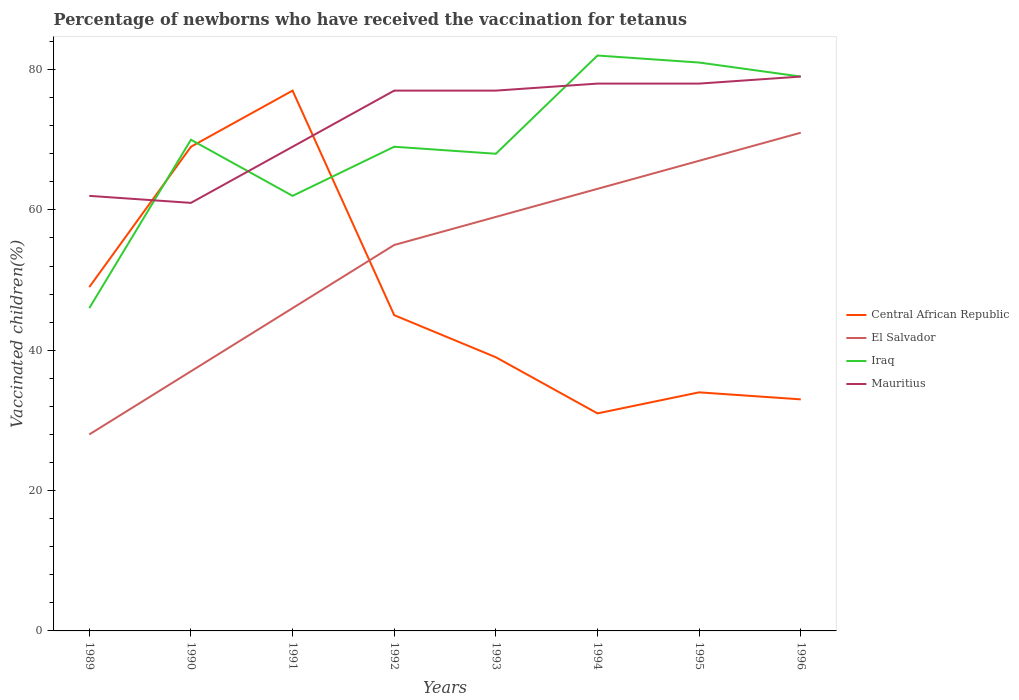How many different coloured lines are there?
Your answer should be very brief. 4. Across all years, what is the maximum percentage of vaccinated children in Central African Republic?
Provide a short and direct response. 31. What is the total percentage of vaccinated children in Central African Republic in the graph?
Provide a short and direct response. 8. What is the difference between the highest and the second highest percentage of vaccinated children in Central African Republic?
Your answer should be compact. 46. What is the difference between two consecutive major ticks on the Y-axis?
Offer a very short reply. 20. Are the values on the major ticks of Y-axis written in scientific E-notation?
Your answer should be compact. No. Does the graph contain grids?
Make the answer very short. No. Where does the legend appear in the graph?
Make the answer very short. Center right. What is the title of the graph?
Make the answer very short. Percentage of newborns who have received the vaccination for tetanus. What is the label or title of the X-axis?
Your answer should be very brief. Years. What is the label or title of the Y-axis?
Provide a short and direct response. Vaccinated children(%). What is the Vaccinated children(%) of Iraq in 1989?
Your answer should be very brief. 46. What is the Vaccinated children(%) in Mauritius in 1989?
Your answer should be very brief. 62. What is the Vaccinated children(%) of Central African Republic in 1990?
Make the answer very short. 69. What is the Vaccinated children(%) in Iraq in 1990?
Ensure brevity in your answer.  70. What is the Vaccinated children(%) in Mauritius in 1990?
Provide a short and direct response. 61. What is the Vaccinated children(%) of Central African Republic in 1991?
Keep it short and to the point. 77. What is the Vaccinated children(%) in El Salvador in 1991?
Provide a succinct answer. 46. What is the Vaccinated children(%) in El Salvador in 1992?
Ensure brevity in your answer.  55. What is the Vaccinated children(%) of Iraq in 1992?
Ensure brevity in your answer.  69. What is the Vaccinated children(%) in Mauritius in 1992?
Your answer should be compact. 77. What is the Vaccinated children(%) of Central African Republic in 1993?
Offer a terse response. 39. What is the Vaccinated children(%) in El Salvador in 1993?
Keep it short and to the point. 59. What is the Vaccinated children(%) of Central African Republic in 1994?
Provide a short and direct response. 31. What is the Vaccinated children(%) of Iraq in 1995?
Your response must be concise. 81. What is the Vaccinated children(%) in Mauritius in 1995?
Give a very brief answer. 78. What is the Vaccinated children(%) in Iraq in 1996?
Provide a short and direct response. 79. What is the Vaccinated children(%) in Mauritius in 1996?
Provide a short and direct response. 79. Across all years, what is the maximum Vaccinated children(%) in Central African Republic?
Ensure brevity in your answer.  77. Across all years, what is the maximum Vaccinated children(%) in Iraq?
Your answer should be very brief. 82. Across all years, what is the maximum Vaccinated children(%) of Mauritius?
Provide a short and direct response. 79. Across all years, what is the minimum Vaccinated children(%) in Central African Republic?
Ensure brevity in your answer.  31. Across all years, what is the minimum Vaccinated children(%) of El Salvador?
Make the answer very short. 28. What is the total Vaccinated children(%) of Central African Republic in the graph?
Your answer should be very brief. 377. What is the total Vaccinated children(%) of El Salvador in the graph?
Keep it short and to the point. 426. What is the total Vaccinated children(%) in Iraq in the graph?
Your answer should be very brief. 557. What is the total Vaccinated children(%) of Mauritius in the graph?
Provide a short and direct response. 581. What is the difference between the Vaccinated children(%) in Iraq in 1989 and that in 1990?
Ensure brevity in your answer.  -24. What is the difference between the Vaccinated children(%) in Iraq in 1989 and that in 1991?
Offer a very short reply. -16. What is the difference between the Vaccinated children(%) in El Salvador in 1989 and that in 1993?
Ensure brevity in your answer.  -31. What is the difference between the Vaccinated children(%) in Iraq in 1989 and that in 1993?
Provide a short and direct response. -22. What is the difference between the Vaccinated children(%) in El Salvador in 1989 and that in 1994?
Offer a very short reply. -35. What is the difference between the Vaccinated children(%) of Iraq in 1989 and that in 1994?
Your answer should be compact. -36. What is the difference between the Vaccinated children(%) in El Salvador in 1989 and that in 1995?
Offer a very short reply. -39. What is the difference between the Vaccinated children(%) of Iraq in 1989 and that in 1995?
Ensure brevity in your answer.  -35. What is the difference between the Vaccinated children(%) of Mauritius in 1989 and that in 1995?
Offer a terse response. -16. What is the difference between the Vaccinated children(%) of Central African Republic in 1989 and that in 1996?
Provide a succinct answer. 16. What is the difference between the Vaccinated children(%) in El Salvador in 1989 and that in 1996?
Your response must be concise. -43. What is the difference between the Vaccinated children(%) of Iraq in 1989 and that in 1996?
Offer a terse response. -33. What is the difference between the Vaccinated children(%) of Mauritius in 1989 and that in 1996?
Your answer should be very brief. -17. What is the difference between the Vaccinated children(%) in Mauritius in 1990 and that in 1991?
Ensure brevity in your answer.  -8. What is the difference between the Vaccinated children(%) of El Salvador in 1990 and that in 1992?
Provide a short and direct response. -18. What is the difference between the Vaccinated children(%) of Iraq in 1990 and that in 1992?
Your answer should be very brief. 1. What is the difference between the Vaccinated children(%) of Mauritius in 1990 and that in 1992?
Offer a terse response. -16. What is the difference between the Vaccinated children(%) of Central African Republic in 1990 and that in 1993?
Your response must be concise. 30. What is the difference between the Vaccinated children(%) of Central African Republic in 1990 and that in 1994?
Give a very brief answer. 38. What is the difference between the Vaccinated children(%) in El Salvador in 1990 and that in 1994?
Ensure brevity in your answer.  -26. What is the difference between the Vaccinated children(%) in Iraq in 1990 and that in 1994?
Ensure brevity in your answer.  -12. What is the difference between the Vaccinated children(%) of Mauritius in 1990 and that in 1994?
Your answer should be compact. -17. What is the difference between the Vaccinated children(%) of El Salvador in 1990 and that in 1995?
Ensure brevity in your answer.  -30. What is the difference between the Vaccinated children(%) in Iraq in 1990 and that in 1995?
Your answer should be compact. -11. What is the difference between the Vaccinated children(%) in El Salvador in 1990 and that in 1996?
Offer a terse response. -34. What is the difference between the Vaccinated children(%) in Mauritius in 1990 and that in 1996?
Provide a succinct answer. -18. What is the difference between the Vaccinated children(%) of El Salvador in 1991 and that in 1992?
Your answer should be very brief. -9. What is the difference between the Vaccinated children(%) in Mauritius in 1991 and that in 1992?
Ensure brevity in your answer.  -8. What is the difference between the Vaccinated children(%) of Central African Republic in 1991 and that in 1993?
Your answer should be very brief. 38. What is the difference between the Vaccinated children(%) in El Salvador in 1991 and that in 1993?
Your answer should be compact. -13. What is the difference between the Vaccinated children(%) of Iraq in 1991 and that in 1993?
Your response must be concise. -6. What is the difference between the Vaccinated children(%) of Mauritius in 1991 and that in 1993?
Offer a terse response. -8. What is the difference between the Vaccinated children(%) in El Salvador in 1991 and that in 1994?
Provide a short and direct response. -17. What is the difference between the Vaccinated children(%) in Mauritius in 1991 and that in 1994?
Your answer should be very brief. -9. What is the difference between the Vaccinated children(%) in El Salvador in 1991 and that in 1995?
Offer a very short reply. -21. What is the difference between the Vaccinated children(%) in Iraq in 1991 and that in 1995?
Ensure brevity in your answer.  -19. What is the difference between the Vaccinated children(%) in El Salvador in 1991 and that in 1996?
Your response must be concise. -25. What is the difference between the Vaccinated children(%) of Iraq in 1991 and that in 1996?
Make the answer very short. -17. What is the difference between the Vaccinated children(%) in Mauritius in 1991 and that in 1996?
Keep it short and to the point. -10. What is the difference between the Vaccinated children(%) of Central African Republic in 1992 and that in 1993?
Ensure brevity in your answer.  6. What is the difference between the Vaccinated children(%) of Mauritius in 1992 and that in 1993?
Your answer should be compact. 0. What is the difference between the Vaccinated children(%) of El Salvador in 1992 and that in 1994?
Ensure brevity in your answer.  -8. What is the difference between the Vaccinated children(%) in Iraq in 1992 and that in 1994?
Your answer should be very brief. -13. What is the difference between the Vaccinated children(%) of Central African Republic in 1992 and that in 1995?
Keep it short and to the point. 11. What is the difference between the Vaccinated children(%) in El Salvador in 1992 and that in 1995?
Your answer should be compact. -12. What is the difference between the Vaccinated children(%) in Iraq in 1992 and that in 1995?
Provide a succinct answer. -12. What is the difference between the Vaccinated children(%) of El Salvador in 1992 and that in 1996?
Make the answer very short. -16. What is the difference between the Vaccinated children(%) of Mauritius in 1993 and that in 1994?
Your response must be concise. -1. What is the difference between the Vaccinated children(%) in Central African Republic in 1993 and that in 1995?
Give a very brief answer. 5. What is the difference between the Vaccinated children(%) of Iraq in 1993 and that in 1995?
Keep it short and to the point. -13. What is the difference between the Vaccinated children(%) of Mauritius in 1993 and that in 1995?
Give a very brief answer. -1. What is the difference between the Vaccinated children(%) of Central African Republic in 1993 and that in 1996?
Provide a short and direct response. 6. What is the difference between the Vaccinated children(%) of El Salvador in 1993 and that in 1996?
Give a very brief answer. -12. What is the difference between the Vaccinated children(%) of Iraq in 1993 and that in 1996?
Provide a short and direct response. -11. What is the difference between the Vaccinated children(%) of Mauritius in 1993 and that in 1996?
Your answer should be very brief. -2. What is the difference between the Vaccinated children(%) of El Salvador in 1994 and that in 1995?
Provide a short and direct response. -4. What is the difference between the Vaccinated children(%) of Iraq in 1994 and that in 1995?
Your answer should be very brief. 1. What is the difference between the Vaccinated children(%) in Mauritius in 1994 and that in 1995?
Your response must be concise. 0. What is the difference between the Vaccinated children(%) in Central African Republic in 1994 and that in 1996?
Offer a very short reply. -2. What is the difference between the Vaccinated children(%) of El Salvador in 1994 and that in 1996?
Give a very brief answer. -8. What is the difference between the Vaccinated children(%) of Central African Republic in 1995 and that in 1996?
Ensure brevity in your answer.  1. What is the difference between the Vaccinated children(%) in El Salvador in 1995 and that in 1996?
Your answer should be very brief. -4. What is the difference between the Vaccinated children(%) of Iraq in 1995 and that in 1996?
Provide a succinct answer. 2. What is the difference between the Vaccinated children(%) in Central African Republic in 1989 and the Vaccinated children(%) in El Salvador in 1990?
Make the answer very short. 12. What is the difference between the Vaccinated children(%) in Central African Republic in 1989 and the Vaccinated children(%) in Iraq in 1990?
Keep it short and to the point. -21. What is the difference between the Vaccinated children(%) in Central African Republic in 1989 and the Vaccinated children(%) in Mauritius in 1990?
Provide a short and direct response. -12. What is the difference between the Vaccinated children(%) in El Salvador in 1989 and the Vaccinated children(%) in Iraq in 1990?
Keep it short and to the point. -42. What is the difference between the Vaccinated children(%) of El Salvador in 1989 and the Vaccinated children(%) of Mauritius in 1990?
Your answer should be compact. -33. What is the difference between the Vaccinated children(%) of Central African Republic in 1989 and the Vaccinated children(%) of Mauritius in 1991?
Your answer should be very brief. -20. What is the difference between the Vaccinated children(%) of El Salvador in 1989 and the Vaccinated children(%) of Iraq in 1991?
Offer a terse response. -34. What is the difference between the Vaccinated children(%) of El Salvador in 1989 and the Vaccinated children(%) of Mauritius in 1991?
Give a very brief answer. -41. What is the difference between the Vaccinated children(%) of Central African Republic in 1989 and the Vaccinated children(%) of Iraq in 1992?
Offer a terse response. -20. What is the difference between the Vaccinated children(%) in El Salvador in 1989 and the Vaccinated children(%) in Iraq in 1992?
Offer a terse response. -41. What is the difference between the Vaccinated children(%) in El Salvador in 1989 and the Vaccinated children(%) in Mauritius in 1992?
Provide a short and direct response. -49. What is the difference between the Vaccinated children(%) in Iraq in 1989 and the Vaccinated children(%) in Mauritius in 1992?
Offer a very short reply. -31. What is the difference between the Vaccinated children(%) of Central African Republic in 1989 and the Vaccinated children(%) of El Salvador in 1993?
Provide a short and direct response. -10. What is the difference between the Vaccinated children(%) in Central African Republic in 1989 and the Vaccinated children(%) in Mauritius in 1993?
Your answer should be very brief. -28. What is the difference between the Vaccinated children(%) in El Salvador in 1989 and the Vaccinated children(%) in Iraq in 1993?
Your answer should be very brief. -40. What is the difference between the Vaccinated children(%) in El Salvador in 1989 and the Vaccinated children(%) in Mauritius in 1993?
Your answer should be compact. -49. What is the difference between the Vaccinated children(%) in Iraq in 1989 and the Vaccinated children(%) in Mauritius in 1993?
Give a very brief answer. -31. What is the difference between the Vaccinated children(%) of Central African Republic in 1989 and the Vaccinated children(%) of Iraq in 1994?
Ensure brevity in your answer.  -33. What is the difference between the Vaccinated children(%) of Central African Republic in 1989 and the Vaccinated children(%) of Mauritius in 1994?
Make the answer very short. -29. What is the difference between the Vaccinated children(%) of El Salvador in 1989 and the Vaccinated children(%) of Iraq in 1994?
Give a very brief answer. -54. What is the difference between the Vaccinated children(%) in El Salvador in 1989 and the Vaccinated children(%) in Mauritius in 1994?
Your answer should be compact. -50. What is the difference between the Vaccinated children(%) of Iraq in 1989 and the Vaccinated children(%) of Mauritius in 1994?
Provide a succinct answer. -32. What is the difference between the Vaccinated children(%) in Central African Republic in 1989 and the Vaccinated children(%) in El Salvador in 1995?
Your answer should be compact. -18. What is the difference between the Vaccinated children(%) in Central African Republic in 1989 and the Vaccinated children(%) in Iraq in 1995?
Ensure brevity in your answer.  -32. What is the difference between the Vaccinated children(%) in El Salvador in 1989 and the Vaccinated children(%) in Iraq in 1995?
Give a very brief answer. -53. What is the difference between the Vaccinated children(%) in El Salvador in 1989 and the Vaccinated children(%) in Mauritius in 1995?
Your answer should be compact. -50. What is the difference between the Vaccinated children(%) of Iraq in 1989 and the Vaccinated children(%) of Mauritius in 1995?
Provide a short and direct response. -32. What is the difference between the Vaccinated children(%) in El Salvador in 1989 and the Vaccinated children(%) in Iraq in 1996?
Offer a terse response. -51. What is the difference between the Vaccinated children(%) in El Salvador in 1989 and the Vaccinated children(%) in Mauritius in 1996?
Your answer should be compact. -51. What is the difference between the Vaccinated children(%) in Iraq in 1989 and the Vaccinated children(%) in Mauritius in 1996?
Offer a very short reply. -33. What is the difference between the Vaccinated children(%) of Central African Republic in 1990 and the Vaccinated children(%) of Iraq in 1991?
Give a very brief answer. 7. What is the difference between the Vaccinated children(%) in El Salvador in 1990 and the Vaccinated children(%) in Mauritius in 1991?
Make the answer very short. -32. What is the difference between the Vaccinated children(%) in Iraq in 1990 and the Vaccinated children(%) in Mauritius in 1991?
Provide a short and direct response. 1. What is the difference between the Vaccinated children(%) of Central African Republic in 1990 and the Vaccinated children(%) of Iraq in 1992?
Your response must be concise. 0. What is the difference between the Vaccinated children(%) in El Salvador in 1990 and the Vaccinated children(%) in Iraq in 1992?
Give a very brief answer. -32. What is the difference between the Vaccinated children(%) of El Salvador in 1990 and the Vaccinated children(%) of Mauritius in 1992?
Provide a short and direct response. -40. What is the difference between the Vaccinated children(%) in Central African Republic in 1990 and the Vaccinated children(%) in Mauritius in 1993?
Provide a short and direct response. -8. What is the difference between the Vaccinated children(%) in El Salvador in 1990 and the Vaccinated children(%) in Iraq in 1993?
Your response must be concise. -31. What is the difference between the Vaccinated children(%) in El Salvador in 1990 and the Vaccinated children(%) in Mauritius in 1993?
Offer a terse response. -40. What is the difference between the Vaccinated children(%) of Central African Republic in 1990 and the Vaccinated children(%) of Iraq in 1994?
Keep it short and to the point. -13. What is the difference between the Vaccinated children(%) in Central African Republic in 1990 and the Vaccinated children(%) in Mauritius in 1994?
Ensure brevity in your answer.  -9. What is the difference between the Vaccinated children(%) in El Salvador in 1990 and the Vaccinated children(%) in Iraq in 1994?
Your answer should be compact. -45. What is the difference between the Vaccinated children(%) of El Salvador in 1990 and the Vaccinated children(%) of Mauritius in 1994?
Offer a very short reply. -41. What is the difference between the Vaccinated children(%) in Iraq in 1990 and the Vaccinated children(%) in Mauritius in 1994?
Make the answer very short. -8. What is the difference between the Vaccinated children(%) of Central African Republic in 1990 and the Vaccinated children(%) of El Salvador in 1995?
Ensure brevity in your answer.  2. What is the difference between the Vaccinated children(%) in El Salvador in 1990 and the Vaccinated children(%) in Iraq in 1995?
Offer a very short reply. -44. What is the difference between the Vaccinated children(%) in El Salvador in 1990 and the Vaccinated children(%) in Mauritius in 1995?
Your response must be concise. -41. What is the difference between the Vaccinated children(%) of Central African Republic in 1990 and the Vaccinated children(%) of Iraq in 1996?
Provide a succinct answer. -10. What is the difference between the Vaccinated children(%) in Central African Republic in 1990 and the Vaccinated children(%) in Mauritius in 1996?
Your answer should be very brief. -10. What is the difference between the Vaccinated children(%) of El Salvador in 1990 and the Vaccinated children(%) of Iraq in 1996?
Give a very brief answer. -42. What is the difference between the Vaccinated children(%) of El Salvador in 1990 and the Vaccinated children(%) of Mauritius in 1996?
Make the answer very short. -42. What is the difference between the Vaccinated children(%) of Iraq in 1990 and the Vaccinated children(%) of Mauritius in 1996?
Make the answer very short. -9. What is the difference between the Vaccinated children(%) of Central African Republic in 1991 and the Vaccinated children(%) of El Salvador in 1992?
Give a very brief answer. 22. What is the difference between the Vaccinated children(%) in Central African Republic in 1991 and the Vaccinated children(%) in Iraq in 1992?
Offer a terse response. 8. What is the difference between the Vaccinated children(%) of El Salvador in 1991 and the Vaccinated children(%) of Mauritius in 1992?
Offer a very short reply. -31. What is the difference between the Vaccinated children(%) in El Salvador in 1991 and the Vaccinated children(%) in Iraq in 1993?
Your answer should be very brief. -22. What is the difference between the Vaccinated children(%) in El Salvador in 1991 and the Vaccinated children(%) in Mauritius in 1993?
Ensure brevity in your answer.  -31. What is the difference between the Vaccinated children(%) of Central African Republic in 1991 and the Vaccinated children(%) of El Salvador in 1994?
Give a very brief answer. 14. What is the difference between the Vaccinated children(%) of Central African Republic in 1991 and the Vaccinated children(%) of Iraq in 1994?
Offer a terse response. -5. What is the difference between the Vaccinated children(%) in El Salvador in 1991 and the Vaccinated children(%) in Iraq in 1994?
Your answer should be very brief. -36. What is the difference between the Vaccinated children(%) in El Salvador in 1991 and the Vaccinated children(%) in Mauritius in 1994?
Provide a short and direct response. -32. What is the difference between the Vaccinated children(%) in Iraq in 1991 and the Vaccinated children(%) in Mauritius in 1994?
Ensure brevity in your answer.  -16. What is the difference between the Vaccinated children(%) in Central African Republic in 1991 and the Vaccinated children(%) in El Salvador in 1995?
Give a very brief answer. 10. What is the difference between the Vaccinated children(%) in Central African Republic in 1991 and the Vaccinated children(%) in Mauritius in 1995?
Your response must be concise. -1. What is the difference between the Vaccinated children(%) in El Salvador in 1991 and the Vaccinated children(%) in Iraq in 1995?
Offer a terse response. -35. What is the difference between the Vaccinated children(%) of El Salvador in 1991 and the Vaccinated children(%) of Mauritius in 1995?
Your response must be concise. -32. What is the difference between the Vaccinated children(%) in Iraq in 1991 and the Vaccinated children(%) in Mauritius in 1995?
Your answer should be compact. -16. What is the difference between the Vaccinated children(%) in Central African Republic in 1991 and the Vaccinated children(%) in Mauritius in 1996?
Offer a very short reply. -2. What is the difference between the Vaccinated children(%) in El Salvador in 1991 and the Vaccinated children(%) in Iraq in 1996?
Provide a short and direct response. -33. What is the difference between the Vaccinated children(%) of El Salvador in 1991 and the Vaccinated children(%) of Mauritius in 1996?
Provide a short and direct response. -33. What is the difference between the Vaccinated children(%) in Central African Republic in 1992 and the Vaccinated children(%) in El Salvador in 1993?
Ensure brevity in your answer.  -14. What is the difference between the Vaccinated children(%) of Central African Republic in 1992 and the Vaccinated children(%) of Mauritius in 1993?
Offer a terse response. -32. What is the difference between the Vaccinated children(%) of El Salvador in 1992 and the Vaccinated children(%) of Iraq in 1993?
Provide a succinct answer. -13. What is the difference between the Vaccinated children(%) in El Salvador in 1992 and the Vaccinated children(%) in Mauritius in 1993?
Provide a succinct answer. -22. What is the difference between the Vaccinated children(%) of Central African Republic in 1992 and the Vaccinated children(%) of El Salvador in 1994?
Offer a very short reply. -18. What is the difference between the Vaccinated children(%) in Central African Republic in 1992 and the Vaccinated children(%) in Iraq in 1994?
Provide a short and direct response. -37. What is the difference between the Vaccinated children(%) in Central African Republic in 1992 and the Vaccinated children(%) in Mauritius in 1994?
Provide a succinct answer. -33. What is the difference between the Vaccinated children(%) of El Salvador in 1992 and the Vaccinated children(%) of Mauritius in 1994?
Keep it short and to the point. -23. What is the difference between the Vaccinated children(%) of Central African Republic in 1992 and the Vaccinated children(%) of El Salvador in 1995?
Give a very brief answer. -22. What is the difference between the Vaccinated children(%) in Central African Republic in 1992 and the Vaccinated children(%) in Iraq in 1995?
Keep it short and to the point. -36. What is the difference between the Vaccinated children(%) in Central African Republic in 1992 and the Vaccinated children(%) in Mauritius in 1995?
Offer a very short reply. -33. What is the difference between the Vaccinated children(%) in El Salvador in 1992 and the Vaccinated children(%) in Mauritius in 1995?
Offer a terse response. -23. What is the difference between the Vaccinated children(%) in Iraq in 1992 and the Vaccinated children(%) in Mauritius in 1995?
Offer a terse response. -9. What is the difference between the Vaccinated children(%) in Central African Republic in 1992 and the Vaccinated children(%) in El Salvador in 1996?
Make the answer very short. -26. What is the difference between the Vaccinated children(%) in Central African Republic in 1992 and the Vaccinated children(%) in Iraq in 1996?
Ensure brevity in your answer.  -34. What is the difference between the Vaccinated children(%) of Central African Republic in 1992 and the Vaccinated children(%) of Mauritius in 1996?
Make the answer very short. -34. What is the difference between the Vaccinated children(%) of El Salvador in 1992 and the Vaccinated children(%) of Iraq in 1996?
Ensure brevity in your answer.  -24. What is the difference between the Vaccinated children(%) of Central African Republic in 1993 and the Vaccinated children(%) of Iraq in 1994?
Give a very brief answer. -43. What is the difference between the Vaccinated children(%) of Central African Republic in 1993 and the Vaccinated children(%) of Mauritius in 1994?
Ensure brevity in your answer.  -39. What is the difference between the Vaccinated children(%) in El Salvador in 1993 and the Vaccinated children(%) in Iraq in 1994?
Keep it short and to the point. -23. What is the difference between the Vaccinated children(%) in El Salvador in 1993 and the Vaccinated children(%) in Mauritius in 1994?
Your answer should be compact. -19. What is the difference between the Vaccinated children(%) of Central African Republic in 1993 and the Vaccinated children(%) of Iraq in 1995?
Provide a succinct answer. -42. What is the difference between the Vaccinated children(%) in Central African Republic in 1993 and the Vaccinated children(%) in Mauritius in 1995?
Provide a succinct answer. -39. What is the difference between the Vaccinated children(%) of El Salvador in 1993 and the Vaccinated children(%) of Iraq in 1995?
Your response must be concise. -22. What is the difference between the Vaccinated children(%) in El Salvador in 1993 and the Vaccinated children(%) in Mauritius in 1995?
Your answer should be very brief. -19. What is the difference between the Vaccinated children(%) in Central African Republic in 1993 and the Vaccinated children(%) in El Salvador in 1996?
Provide a succinct answer. -32. What is the difference between the Vaccinated children(%) of Central African Republic in 1993 and the Vaccinated children(%) of Mauritius in 1996?
Provide a succinct answer. -40. What is the difference between the Vaccinated children(%) of El Salvador in 1993 and the Vaccinated children(%) of Iraq in 1996?
Provide a succinct answer. -20. What is the difference between the Vaccinated children(%) in El Salvador in 1993 and the Vaccinated children(%) in Mauritius in 1996?
Your response must be concise. -20. What is the difference between the Vaccinated children(%) of Iraq in 1993 and the Vaccinated children(%) of Mauritius in 1996?
Make the answer very short. -11. What is the difference between the Vaccinated children(%) in Central African Republic in 1994 and the Vaccinated children(%) in El Salvador in 1995?
Your answer should be very brief. -36. What is the difference between the Vaccinated children(%) in Central African Republic in 1994 and the Vaccinated children(%) in Iraq in 1995?
Offer a very short reply. -50. What is the difference between the Vaccinated children(%) in Central African Republic in 1994 and the Vaccinated children(%) in Mauritius in 1995?
Provide a succinct answer. -47. What is the difference between the Vaccinated children(%) of Central African Republic in 1994 and the Vaccinated children(%) of Iraq in 1996?
Provide a short and direct response. -48. What is the difference between the Vaccinated children(%) in Central African Republic in 1994 and the Vaccinated children(%) in Mauritius in 1996?
Offer a terse response. -48. What is the difference between the Vaccinated children(%) in El Salvador in 1994 and the Vaccinated children(%) in Iraq in 1996?
Give a very brief answer. -16. What is the difference between the Vaccinated children(%) in El Salvador in 1994 and the Vaccinated children(%) in Mauritius in 1996?
Give a very brief answer. -16. What is the difference between the Vaccinated children(%) in Central African Republic in 1995 and the Vaccinated children(%) in El Salvador in 1996?
Offer a terse response. -37. What is the difference between the Vaccinated children(%) in Central African Republic in 1995 and the Vaccinated children(%) in Iraq in 1996?
Keep it short and to the point. -45. What is the difference between the Vaccinated children(%) in Central African Republic in 1995 and the Vaccinated children(%) in Mauritius in 1996?
Provide a short and direct response. -45. What is the difference between the Vaccinated children(%) in El Salvador in 1995 and the Vaccinated children(%) in Iraq in 1996?
Your answer should be compact. -12. What is the difference between the Vaccinated children(%) of El Salvador in 1995 and the Vaccinated children(%) of Mauritius in 1996?
Your answer should be compact. -12. What is the average Vaccinated children(%) in Central African Republic per year?
Offer a very short reply. 47.12. What is the average Vaccinated children(%) in El Salvador per year?
Your answer should be very brief. 53.25. What is the average Vaccinated children(%) of Iraq per year?
Give a very brief answer. 69.62. What is the average Vaccinated children(%) in Mauritius per year?
Your response must be concise. 72.62. In the year 1989, what is the difference between the Vaccinated children(%) of Central African Republic and Vaccinated children(%) of Mauritius?
Your response must be concise. -13. In the year 1989, what is the difference between the Vaccinated children(%) in El Salvador and Vaccinated children(%) in Iraq?
Your answer should be very brief. -18. In the year 1989, what is the difference between the Vaccinated children(%) in El Salvador and Vaccinated children(%) in Mauritius?
Provide a short and direct response. -34. In the year 1989, what is the difference between the Vaccinated children(%) of Iraq and Vaccinated children(%) of Mauritius?
Ensure brevity in your answer.  -16. In the year 1990, what is the difference between the Vaccinated children(%) of Central African Republic and Vaccinated children(%) of El Salvador?
Make the answer very short. 32. In the year 1990, what is the difference between the Vaccinated children(%) in El Salvador and Vaccinated children(%) in Iraq?
Provide a succinct answer. -33. In the year 1990, what is the difference between the Vaccinated children(%) in El Salvador and Vaccinated children(%) in Mauritius?
Offer a very short reply. -24. In the year 1991, what is the difference between the Vaccinated children(%) of Central African Republic and Vaccinated children(%) of Iraq?
Provide a succinct answer. 15. In the year 1991, what is the difference between the Vaccinated children(%) in El Salvador and Vaccinated children(%) in Iraq?
Provide a short and direct response. -16. In the year 1992, what is the difference between the Vaccinated children(%) of Central African Republic and Vaccinated children(%) of Mauritius?
Provide a short and direct response. -32. In the year 1992, what is the difference between the Vaccinated children(%) of El Salvador and Vaccinated children(%) of Mauritius?
Ensure brevity in your answer.  -22. In the year 1992, what is the difference between the Vaccinated children(%) in Iraq and Vaccinated children(%) in Mauritius?
Make the answer very short. -8. In the year 1993, what is the difference between the Vaccinated children(%) of Central African Republic and Vaccinated children(%) of Mauritius?
Your response must be concise. -38. In the year 1993, what is the difference between the Vaccinated children(%) in El Salvador and Vaccinated children(%) in Iraq?
Give a very brief answer. -9. In the year 1993, what is the difference between the Vaccinated children(%) in Iraq and Vaccinated children(%) in Mauritius?
Keep it short and to the point. -9. In the year 1994, what is the difference between the Vaccinated children(%) of Central African Republic and Vaccinated children(%) of El Salvador?
Keep it short and to the point. -32. In the year 1994, what is the difference between the Vaccinated children(%) of Central African Republic and Vaccinated children(%) of Iraq?
Your answer should be very brief. -51. In the year 1994, what is the difference between the Vaccinated children(%) of Central African Republic and Vaccinated children(%) of Mauritius?
Your answer should be compact. -47. In the year 1994, what is the difference between the Vaccinated children(%) of El Salvador and Vaccinated children(%) of Iraq?
Your answer should be compact. -19. In the year 1994, what is the difference between the Vaccinated children(%) of El Salvador and Vaccinated children(%) of Mauritius?
Give a very brief answer. -15. In the year 1995, what is the difference between the Vaccinated children(%) in Central African Republic and Vaccinated children(%) in El Salvador?
Your response must be concise. -33. In the year 1995, what is the difference between the Vaccinated children(%) in Central African Republic and Vaccinated children(%) in Iraq?
Your answer should be compact. -47. In the year 1995, what is the difference between the Vaccinated children(%) of Central African Republic and Vaccinated children(%) of Mauritius?
Give a very brief answer. -44. In the year 1995, what is the difference between the Vaccinated children(%) in El Salvador and Vaccinated children(%) in Iraq?
Keep it short and to the point. -14. In the year 1995, what is the difference between the Vaccinated children(%) of El Salvador and Vaccinated children(%) of Mauritius?
Provide a short and direct response. -11. In the year 1995, what is the difference between the Vaccinated children(%) of Iraq and Vaccinated children(%) of Mauritius?
Offer a terse response. 3. In the year 1996, what is the difference between the Vaccinated children(%) in Central African Republic and Vaccinated children(%) in El Salvador?
Keep it short and to the point. -38. In the year 1996, what is the difference between the Vaccinated children(%) of Central African Republic and Vaccinated children(%) of Iraq?
Provide a short and direct response. -46. In the year 1996, what is the difference between the Vaccinated children(%) of Central African Republic and Vaccinated children(%) of Mauritius?
Your answer should be compact. -46. In the year 1996, what is the difference between the Vaccinated children(%) in El Salvador and Vaccinated children(%) in Mauritius?
Your response must be concise. -8. What is the ratio of the Vaccinated children(%) of Central African Republic in 1989 to that in 1990?
Provide a succinct answer. 0.71. What is the ratio of the Vaccinated children(%) of El Salvador in 1989 to that in 1990?
Your response must be concise. 0.76. What is the ratio of the Vaccinated children(%) of Iraq in 1989 to that in 1990?
Offer a terse response. 0.66. What is the ratio of the Vaccinated children(%) of Mauritius in 1989 to that in 1990?
Ensure brevity in your answer.  1.02. What is the ratio of the Vaccinated children(%) of Central African Republic in 1989 to that in 1991?
Make the answer very short. 0.64. What is the ratio of the Vaccinated children(%) in El Salvador in 1989 to that in 1991?
Provide a succinct answer. 0.61. What is the ratio of the Vaccinated children(%) in Iraq in 1989 to that in 1991?
Ensure brevity in your answer.  0.74. What is the ratio of the Vaccinated children(%) in Mauritius in 1989 to that in 1991?
Offer a terse response. 0.9. What is the ratio of the Vaccinated children(%) of Central African Republic in 1989 to that in 1992?
Offer a terse response. 1.09. What is the ratio of the Vaccinated children(%) in El Salvador in 1989 to that in 1992?
Your answer should be very brief. 0.51. What is the ratio of the Vaccinated children(%) of Iraq in 1989 to that in 1992?
Offer a very short reply. 0.67. What is the ratio of the Vaccinated children(%) in Mauritius in 1989 to that in 1992?
Give a very brief answer. 0.81. What is the ratio of the Vaccinated children(%) of Central African Republic in 1989 to that in 1993?
Keep it short and to the point. 1.26. What is the ratio of the Vaccinated children(%) of El Salvador in 1989 to that in 1993?
Your answer should be very brief. 0.47. What is the ratio of the Vaccinated children(%) in Iraq in 1989 to that in 1993?
Your response must be concise. 0.68. What is the ratio of the Vaccinated children(%) in Mauritius in 1989 to that in 1993?
Make the answer very short. 0.81. What is the ratio of the Vaccinated children(%) in Central African Republic in 1989 to that in 1994?
Keep it short and to the point. 1.58. What is the ratio of the Vaccinated children(%) of El Salvador in 1989 to that in 1994?
Offer a terse response. 0.44. What is the ratio of the Vaccinated children(%) in Iraq in 1989 to that in 1994?
Your answer should be compact. 0.56. What is the ratio of the Vaccinated children(%) in Mauritius in 1989 to that in 1994?
Provide a short and direct response. 0.79. What is the ratio of the Vaccinated children(%) in Central African Republic in 1989 to that in 1995?
Provide a short and direct response. 1.44. What is the ratio of the Vaccinated children(%) in El Salvador in 1989 to that in 1995?
Your response must be concise. 0.42. What is the ratio of the Vaccinated children(%) in Iraq in 1989 to that in 1995?
Ensure brevity in your answer.  0.57. What is the ratio of the Vaccinated children(%) of Mauritius in 1989 to that in 1995?
Make the answer very short. 0.79. What is the ratio of the Vaccinated children(%) in Central African Republic in 1989 to that in 1996?
Give a very brief answer. 1.48. What is the ratio of the Vaccinated children(%) of El Salvador in 1989 to that in 1996?
Ensure brevity in your answer.  0.39. What is the ratio of the Vaccinated children(%) of Iraq in 1989 to that in 1996?
Your response must be concise. 0.58. What is the ratio of the Vaccinated children(%) in Mauritius in 1989 to that in 1996?
Offer a very short reply. 0.78. What is the ratio of the Vaccinated children(%) in Central African Republic in 1990 to that in 1991?
Give a very brief answer. 0.9. What is the ratio of the Vaccinated children(%) of El Salvador in 1990 to that in 1991?
Make the answer very short. 0.8. What is the ratio of the Vaccinated children(%) of Iraq in 1990 to that in 1991?
Offer a terse response. 1.13. What is the ratio of the Vaccinated children(%) in Mauritius in 1990 to that in 1991?
Your answer should be compact. 0.88. What is the ratio of the Vaccinated children(%) in Central African Republic in 1990 to that in 1992?
Offer a terse response. 1.53. What is the ratio of the Vaccinated children(%) in El Salvador in 1990 to that in 1992?
Offer a terse response. 0.67. What is the ratio of the Vaccinated children(%) of Iraq in 1990 to that in 1992?
Offer a very short reply. 1.01. What is the ratio of the Vaccinated children(%) in Mauritius in 1990 to that in 1992?
Your answer should be compact. 0.79. What is the ratio of the Vaccinated children(%) of Central African Republic in 1990 to that in 1993?
Offer a very short reply. 1.77. What is the ratio of the Vaccinated children(%) in El Salvador in 1990 to that in 1993?
Offer a terse response. 0.63. What is the ratio of the Vaccinated children(%) of Iraq in 1990 to that in 1993?
Give a very brief answer. 1.03. What is the ratio of the Vaccinated children(%) in Mauritius in 1990 to that in 1993?
Keep it short and to the point. 0.79. What is the ratio of the Vaccinated children(%) in Central African Republic in 1990 to that in 1994?
Provide a short and direct response. 2.23. What is the ratio of the Vaccinated children(%) in El Salvador in 1990 to that in 1994?
Give a very brief answer. 0.59. What is the ratio of the Vaccinated children(%) in Iraq in 1990 to that in 1994?
Provide a succinct answer. 0.85. What is the ratio of the Vaccinated children(%) in Mauritius in 1990 to that in 1994?
Keep it short and to the point. 0.78. What is the ratio of the Vaccinated children(%) in Central African Republic in 1990 to that in 1995?
Provide a short and direct response. 2.03. What is the ratio of the Vaccinated children(%) of El Salvador in 1990 to that in 1995?
Provide a succinct answer. 0.55. What is the ratio of the Vaccinated children(%) of Iraq in 1990 to that in 1995?
Your answer should be compact. 0.86. What is the ratio of the Vaccinated children(%) in Mauritius in 1990 to that in 1995?
Provide a short and direct response. 0.78. What is the ratio of the Vaccinated children(%) in Central African Republic in 1990 to that in 1996?
Give a very brief answer. 2.09. What is the ratio of the Vaccinated children(%) in El Salvador in 1990 to that in 1996?
Offer a very short reply. 0.52. What is the ratio of the Vaccinated children(%) of Iraq in 1990 to that in 1996?
Offer a very short reply. 0.89. What is the ratio of the Vaccinated children(%) in Mauritius in 1990 to that in 1996?
Your answer should be compact. 0.77. What is the ratio of the Vaccinated children(%) of Central African Republic in 1991 to that in 1992?
Your response must be concise. 1.71. What is the ratio of the Vaccinated children(%) of El Salvador in 1991 to that in 1992?
Keep it short and to the point. 0.84. What is the ratio of the Vaccinated children(%) in Iraq in 1991 to that in 1992?
Offer a very short reply. 0.9. What is the ratio of the Vaccinated children(%) of Mauritius in 1991 to that in 1992?
Provide a short and direct response. 0.9. What is the ratio of the Vaccinated children(%) in Central African Republic in 1991 to that in 1993?
Ensure brevity in your answer.  1.97. What is the ratio of the Vaccinated children(%) of El Salvador in 1991 to that in 1993?
Your answer should be very brief. 0.78. What is the ratio of the Vaccinated children(%) in Iraq in 1991 to that in 1993?
Provide a short and direct response. 0.91. What is the ratio of the Vaccinated children(%) in Mauritius in 1991 to that in 1993?
Ensure brevity in your answer.  0.9. What is the ratio of the Vaccinated children(%) in Central African Republic in 1991 to that in 1994?
Your answer should be very brief. 2.48. What is the ratio of the Vaccinated children(%) in El Salvador in 1991 to that in 1994?
Make the answer very short. 0.73. What is the ratio of the Vaccinated children(%) of Iraq in 1991 to that in 1994?
Keep it short and to the point. 0.76. What is the ratio of the Vaccinated children(%) of Mauritius in 1991 to that in 1994?
Offer a very short reply. 0.88. What is the ratio of the Vaccinated children(%) of Central African Republic in 1991 to that in 1995?
Provide a short and direct response. 2.26. What is the ratio of the Vaccinated children(%) of El Salvador in 1991 to that in 1995?
Keep it short and to the point. 0.69. What is the ratio of the Vaccinated children(%) in Iraq in 1991 to that in 1995?
Provide a short and direct response. 0.77. What is the ratio of the Vaccinated children(%) in Mauritius in 1991 to that in 1995?
Your response must be concise. 0.88. What is the ratio of the Vaccinated children(%) in Central African Republic in 1991 to that in 1996?
Ensure brevity in your answer.  2.33. What is the ratio of the Vaccinated children(%) of El Salvador in 1991 to that in 1996?
Your response must be concise. 0.65. What is the ratio of the Vaccinated children(%) in Iraq in 1991 to that in 1996?
Your answer should be very brief. 0.78. What is the ratio of the Vaccinated children(%) in Mauritius in 1991 to that in 1996?
Your answer should be compact. 0.87. What is the ratio of the Vaccinated children(%) of Central African Republic in 1992 to that in 1993?
Ensure brevity in your answer.  1.15. What is the ratio of the Vaccinated children(%) of El Salvador in 1992 to that in 1993?
Your answer should be very brief. 0.93. What is the ratio of the Vaccinated children(%) of Iraq in 1992 to that in 1993?
Ensure brevity in your answer.  1.01. What is the ratio of the Vaccinated children(%) of Central African Republic in 1992 to that in 1994?
Make the answer very short. 1.45. What is the ratio of the Vaccinated children(%) in El Salvador in 1992 to that in 1994?
Give a very brief answer. 0.87. What is the ratio of the Vaccinated children(%) in Iraq in 1992 to that in 1994?
Your response must be concise. 0.84. What is the ratio of the Vaccinated children(%) of Mauritius in 1992 to that in 1994?
Ensure brevity in your answer.  0.99. What is the ratio of the Vaccinated children(%) in Central African Republic in 1992 to that in 1995?
Make the answer very short. 1.32. What is the ratio of the Vaccinated children(%) of El Salvador in 1992 to that in 1995?
Your response must be concise. 0.82. What is the ratio of the Vaccinated children(%) of Iraq in 1992 to that in 1995?
Your answer should be compact. 0.85. What is the ratio of the Vaccinated children(%) in Mauritius in 1992 to that in 1995?
Offer a very short reply. 0.99. What is the ratio of the Vaccinated children(%) in Central African Republic in 1992 to that in 1996?
Keep it short and to the point. 1.36. What is the ratio of the Vaccinated children(%) of El Salvador in 1992 to that in 1996?
Your answer should be compact. 0.77. What is the ratio of the Vaccinated children(%) of Iraq in 1992 to that in 1996?
Give a very brief answer. 0.87. What is the ratio of the Vaccinated children(%) in Mauritius in 1992 to that in 1996?
Your response must be concise. 0.97. What is the ratio of the Vaccinated children(%) in Central African Republic in 1993 to that in 1994?
Your response must be concise. 1.26. What is the ratio of the Vaccinated children(%) in El Salvador in 1993 to that in 1994?
Your answer should be very brief. 0.94. What is the ratio of the Vaccinated children(%) in Iraq in 1993 to that in 1994?
Your answer should be very brief. 0.83. What is the ratio of the Vaccinated children(%) of Mauritius in 1993 to that in 1994?
Your answer should be compact. 0.99. What is the ratio of the Vaccinated children(%) in Central African Republic in 1993 to that in 1995?
Provide a short and direct response. 1.15. What is the ratio of the Vaccinated children(%) of El Salvador in 1993 to that in 1995?
Give a very brief answer. 0.88. What is the ratio of the Vaccinated children(%) of Iraq in 1993 to that in 1995?
Ensure brevity in your answer.  0.84. What is the ratio of the Vaccinated children(%) of Mauritius in 1993 to that in 1995?
Offer a terse response. 0.99. What is the ratio of the Vaccinated children(%) of Central African Republic in 1993 to that in 1996?
Your response must be concise. 1.18. What is the ratio of the Vaccinated children(%) of El Salvador in 1993 to that in 1996?
Provide a succinct answer. 0.83. What is the ratio of the Vaccinated children(%) in Iraq in 1993 to that in 1996?
Offer a very short reply. 0.86. What is the ratio of the Vaccinated children(%) in Mauritius in 1993 to that in 1996?
Provide a succinct answer. 0.97. What is the ratio of the Vaccinated children(%) of Central African Republic in 1994 to that in 1995?
Provide a succinct answer. 0.91. What is the ratio of the Vaccinated children(%) in El Salvador in 1994 to that in 1995?
Your answer should be very brief. 0.94. What is the ratio of the Vaccinated children(%) of Iraq in 1994 to that in 1995?
Make the answer very short. 1.01. What is the ratio of the Vaccinated children(%) of Central African Republic in 1994 to that in 1996?
Offer a very short reply. 0.94. What is the ratio of the Vaccinated children(%) of El Salvador in 1994 to that in 1996?
Your response must be concise. 0.89. What is the ratio of the Vaccinated children(%) in Iraq in 1994 to that in 1996?
Provide a short and direct response. 1.04. What is the ratio of the Vaccinated children(%) of Mauritius in 1994 to that in 1996?
Your answer should be compact. 0.99. What is the ratio of the Vaccinated children(%) in Central African Republic in 1995 to that in 1996?
Make the answer very short. 1.03. What is the ratio of the Vaccinated children(%) in El Salvador in 1995 to that in 1996?
Make the answer very short. 0.94. What is the ratio of the Vaccinated children(%) of Iraq in 1995 to that in 1996?
Provide a short and direct response. 1.03. What is the ratio of the Vaccinated children(%) of Mauritius in 1995 to that in 1996?
Your answer should be compact. 0.99. What is the difference between the highest and the second highest Vaccinated children(%) in Central African Republic?
Provide a short and direct response. 8. What is the difference between the highest and the second highest Vaccinated children(%) in Iraq?
Offer a terse response. 1. What is the difference between the highest and the second highest Vaccinated children(%) of Mauritius?
Ensure brevity in your answer.  1. What is the difference between the highest and the lowest Vaccinated children(%) of Central African Republic?
Provide a succinct answer. 46. What is the difference between the highest and the lowest Vaccinated children(%) of El Salvador?
Keep it short and to the point. 43. 